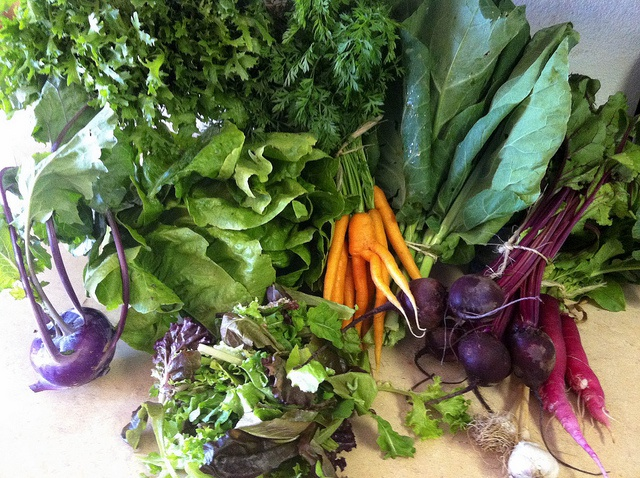Describe the objects in this image and their specific colors. I can see a carrot in lightgreen, orange, red, and black tones in this image. 